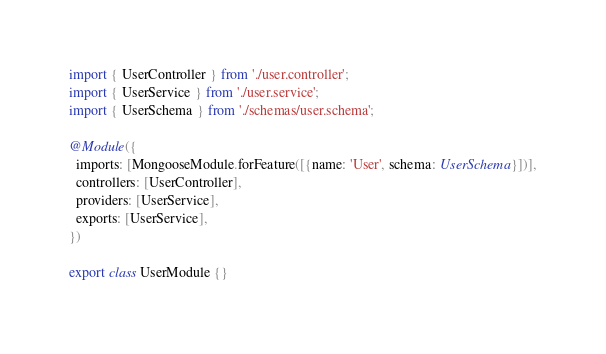Convert code to text. <code><loc_0><loc_0><loc_500><loc_500><_TypeScript_>import { UserController } from './user.controller';
import { UserService } from './user.service';
import { UserSchema } from './schemas/user.schema';

@Module({
  imports: [MongooseModule.forFeature([{name: 'User', schema: UserSchema}])],
  controllers: [UserController],
  providers: [UserService],
  exports: [UserService],
})

export class UserModule {}
</code> 